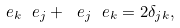<formula> <loc_0><loc_0><loc_500><loc_500>\ e _ { k } \ e _ { j } + \ e _ { j } \ e _ { k } = 2 \delta _ { j k } ,</formula> 